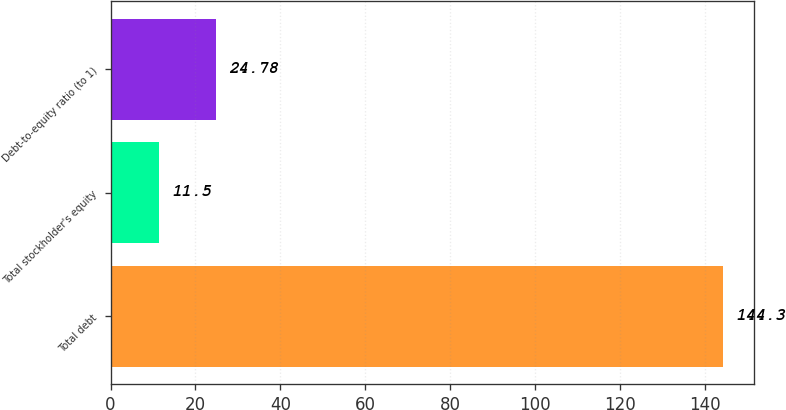<chart> <loc_0><loc_0><loc_500><loc_500><bar_chart><fcel>Total debt<fcel>Total stockholder's equity<fcel>Debt-to-equity ratio (to 1)<nl><fcel>144.3<fcel>11.5<fcel>24.78<nl></chart> 